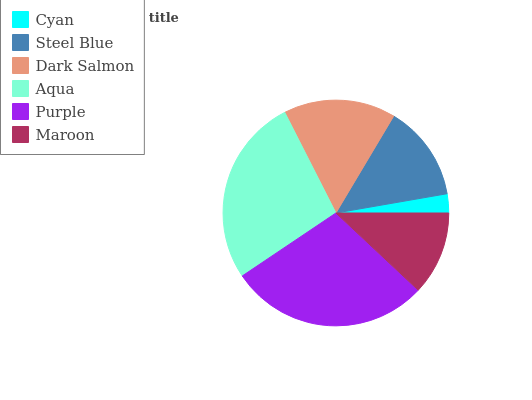Is Cyan the minimum?
Answer yes or no. Yes. Is Purple the maximum?
Answer yes or no. Yes. Is Steel Blue the minimum?
Answer yes or no. No. Is Steel Blue the maximum?
Answer yes or no. No. Is Steel Blue greater than Cyan?
Answer yes or no. Yes. Is Cyan less than Steel Blue?
Answer yes or no. Yes. Is Cyan greater than Steel Blue?
Answer yes or no. No. Is Steel Blue less than Cyan?
Answer yes or no. No. Is Dark Salmon the high median?
Answer yes or no. Yes. Is Steel Blue the low median?
Answer yes or no. Yes. Is Aqua the high median?
Answer yes or no. No. Is Purple the low median?
Answer yes or no. No. 